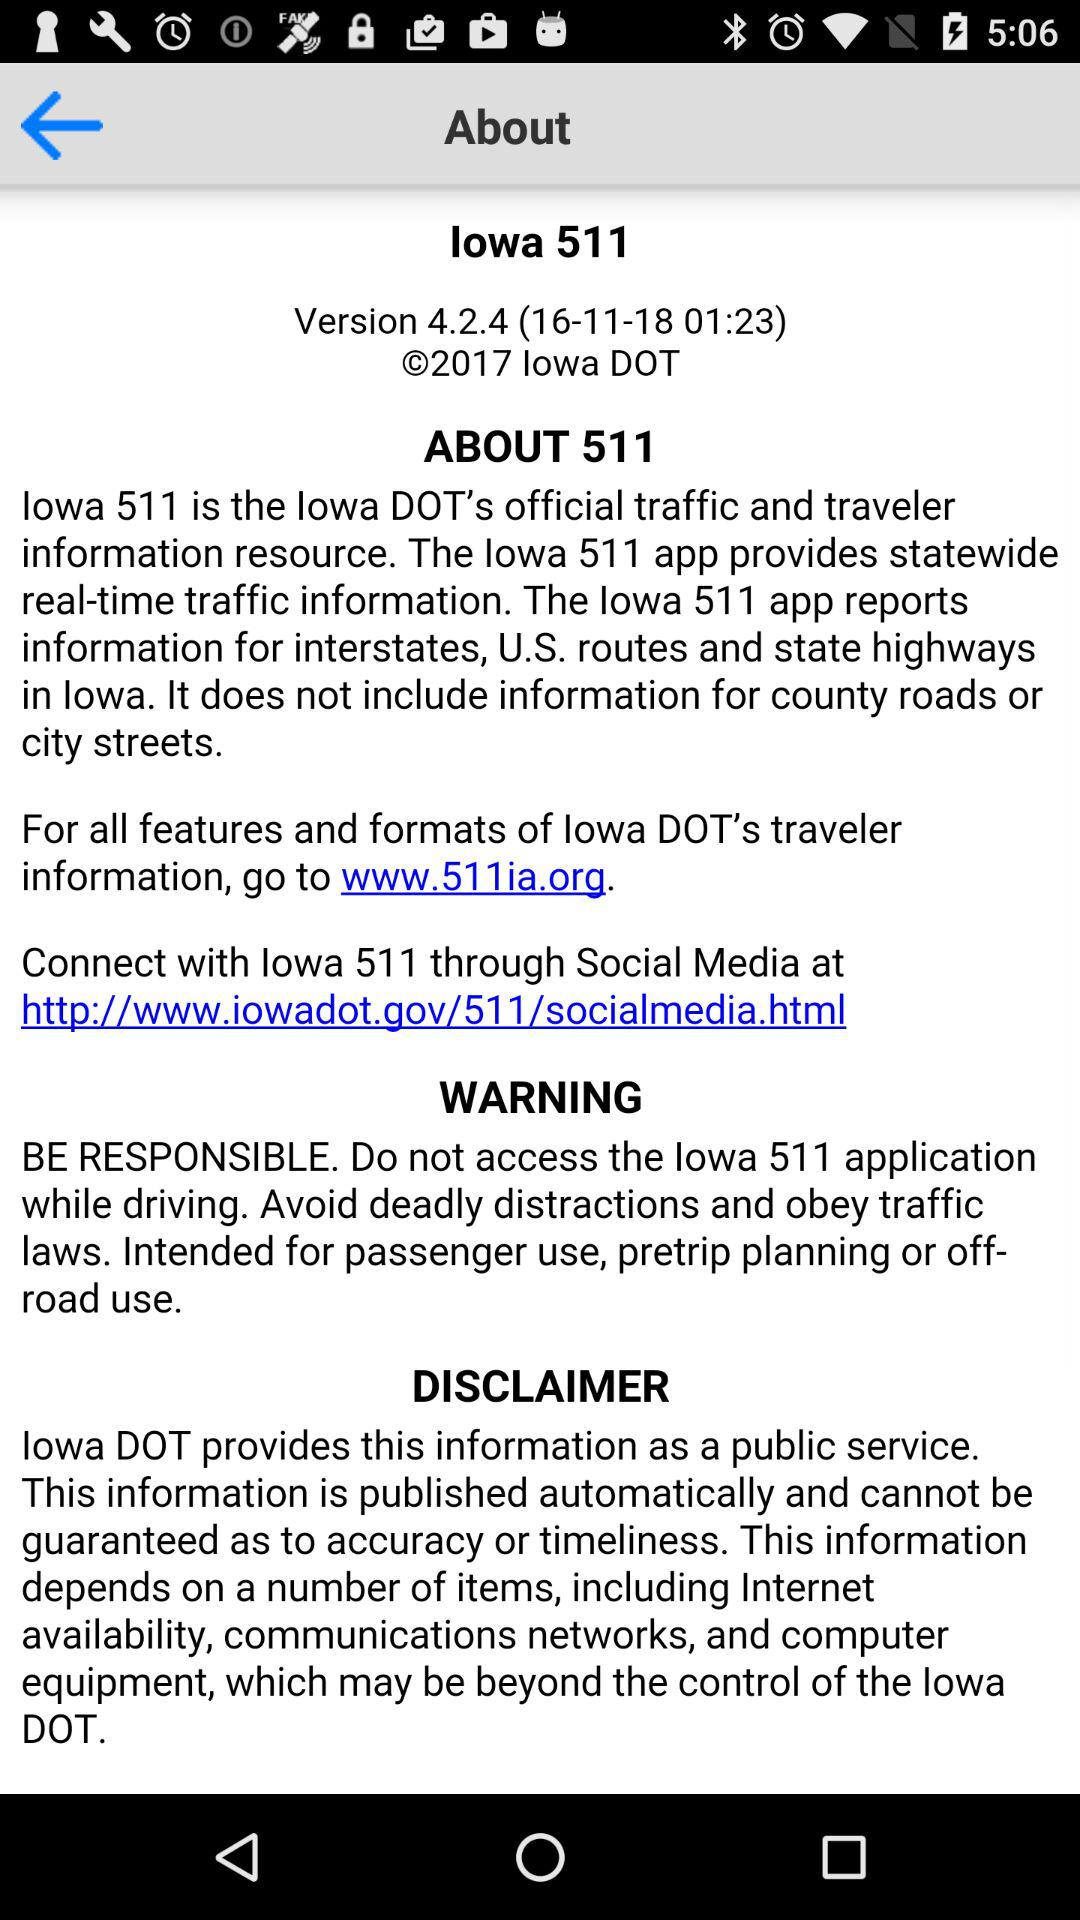What is the application name? The application name is "lowa 511". 